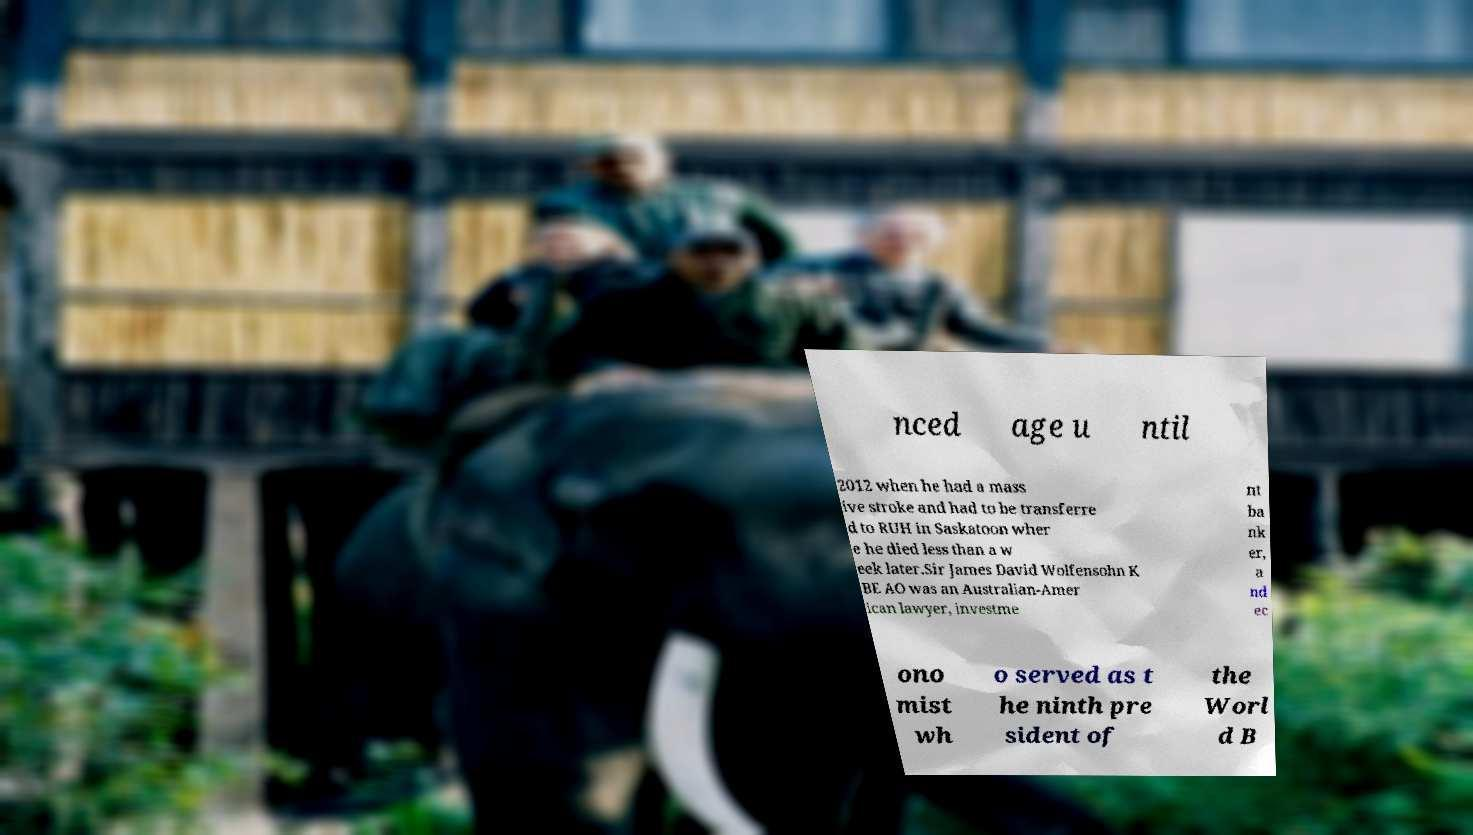Please read and relay the text visible in this image. What does it say? nced age u ntil 2012 when he had a mass ive stroke and had to be transferre d to RUH in Saskatoon wher e he died less than a w eek later.Sir James David Wolfensohn K BE AO was an Australian-Amer ican lawyer, investme nt ba nk er, a nd ec ono mist wh o served as t he ninth pre sident of the Worl d B 